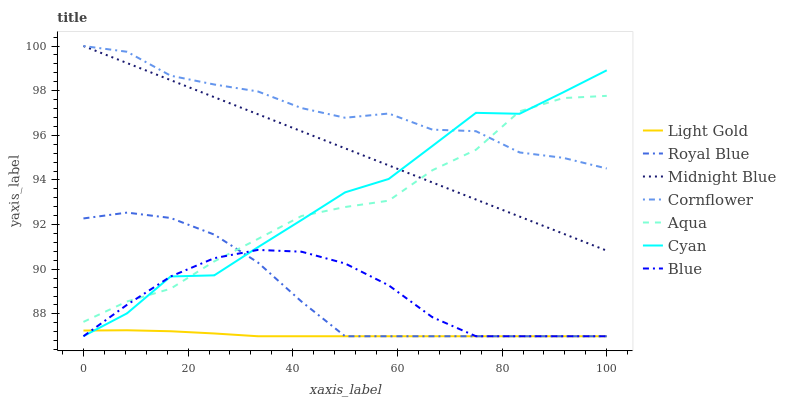Does Light Gold have the minimum area under the curve?
Answer yes or no. Yes. Does Cornflower have the maximum area under the curve?
Answer yes or no. Yes. Does Midnight Blue have the minimum area under the curve?
Answer yes or no. No. Does Midnight Blue have the maximum area under the curve?
Answer yes or no. No. Is Midnight Blue the smoothest?
Answer yes or no. Yes. Is Cyan the roughest?
Answer yes or no. Yes. Is Cornflower the smoothest?
Answer yes or no. No. Is Cornflower the roughest?
Answer yes or no. No. Does Blue have the lowest value?
Answer yes or no. Yes. Does Midnight Blue have the lowest value?
Answer yes or no. No. Does Midnight Blue have the highest value?
Answer yes or no. Yes. Does Aqua have the highest value?
Answer yes or no. No. Is Royal Blue less than Midnight Blue?
Answer yes or no. Yes. Is Midnight Blue greater than Royal Blue?
Answer yes or no. Yes. Does Royal Blue intersect Light Gold?
Answer yes or no. Yes. Is Royal Blue less than Light Gold?
Answer yes or no. No. Is Royal Blue greater than Light Gold?
Answer yes or no. No. Does Royal Blue intersect Midnight Blue?
Answer yes or no. No. 